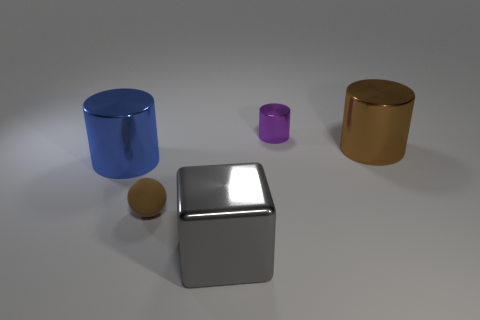Subtract all large cylinders. How many cylinders are left? 1 Add 5 brown rubber spheres. How many objects exist? 10 Subtract all balls. How many objects are left? 4 Subtract all cyan matte objects. Subtract all brown cylinders. How many objects are left? 4 Add 4 big blue shiny cylinders. How many big blue shiny cylinders are left? 5 Add 3 small purple metallic cylinders. How many small purple metallic cylinders exist? 4 Subtract 1 brown cylinders. How many objects are left? 4 